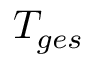<formula> <loc_0><loc_0><loc_500><loc_500>T _ { g e s }</formula> 